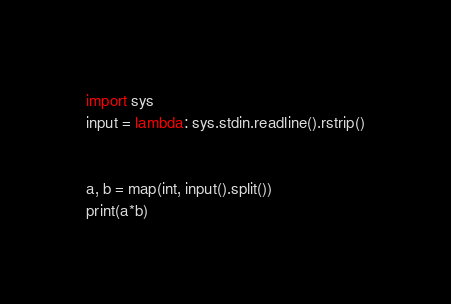<code> <loc_0><loc_0><loc_500><loc_500><_Python_>import sys
input = lambda: sys.stdin.readline().rstrip()


a, b = map(int, input().split())
print(a*b)

</code> 